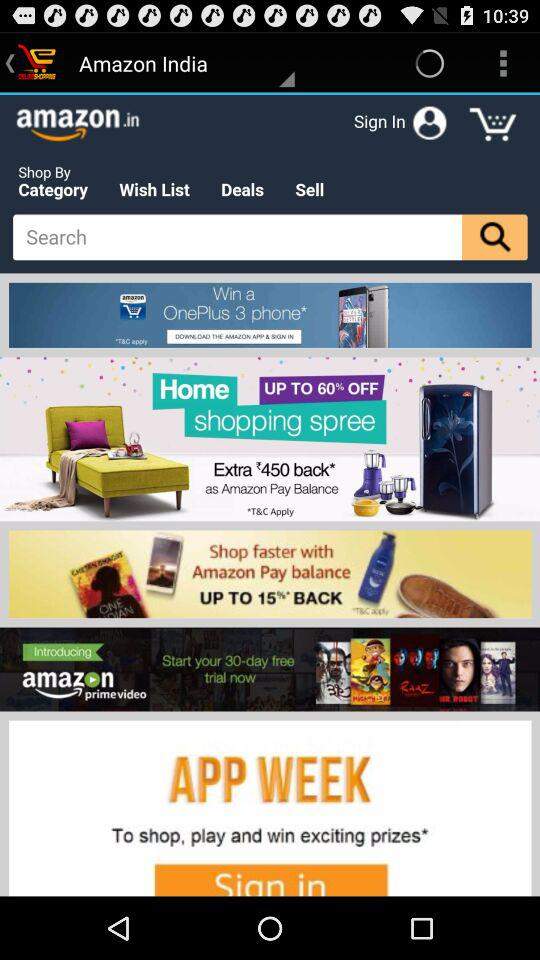How many days are there in the "amazon prime video" free trial? There are 30 days. 